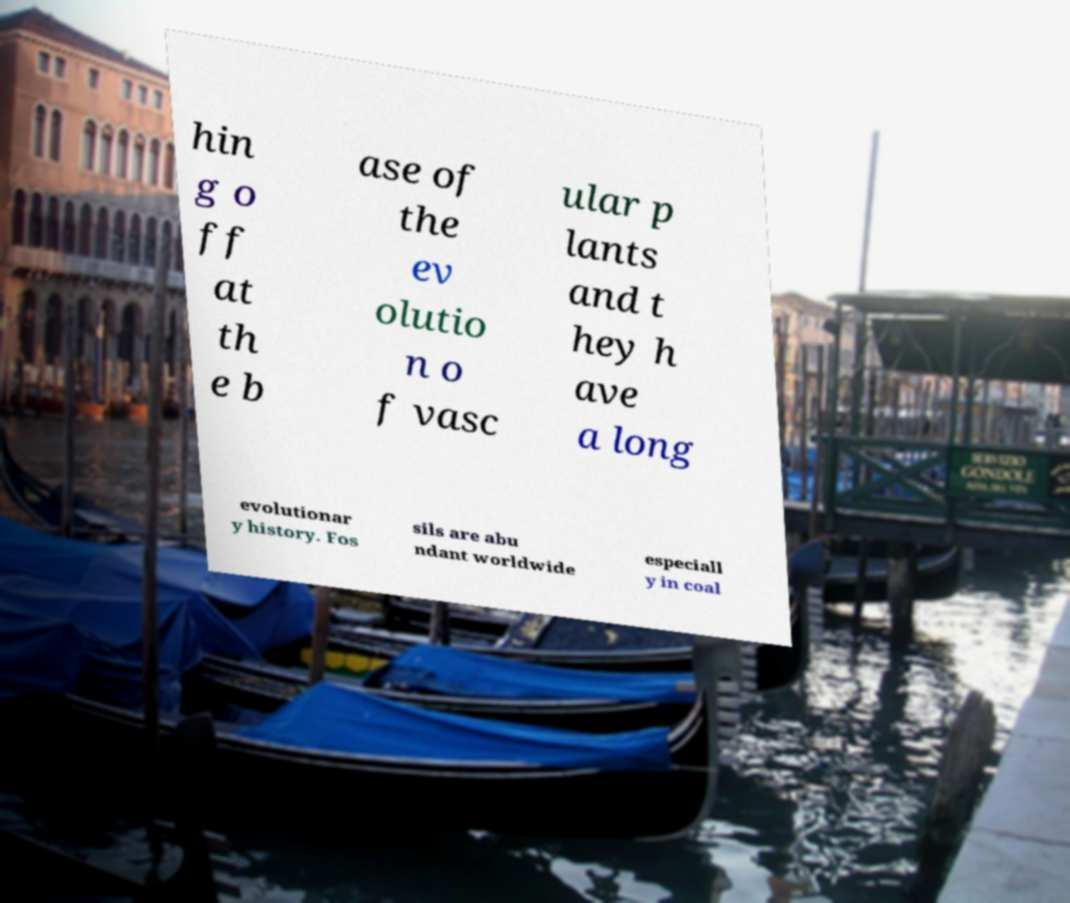I need the written content from this picture converted into text. Can you do that? hin g o ff at th e b ase of the ev olutio n o f vasc ular p lants and t hey h ave a long evolutionar y history. Fos sils are abu ndant worldwide especiall y in coal 